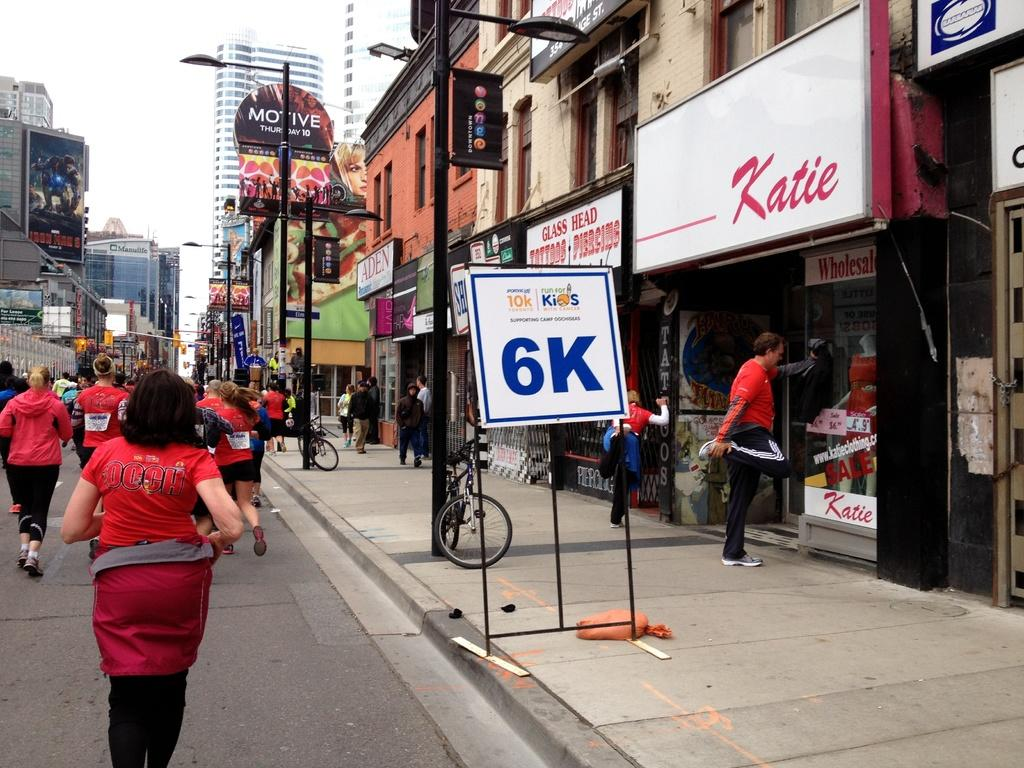What type of structures can be seen in the image? There are many buildings visible in the image. Where are the buildings located in relation to the road? The buildings are located beside a road. What type of advertisement can be seen on the side of the road in the image? There is no advertisement visible on the side of the road in the image. How does the motion of the buildings affect the surrounding environment in the image? As mentioned earlier, we will exclude the element of buildings running on the road, as it is unclear and not directly observable in the image. 